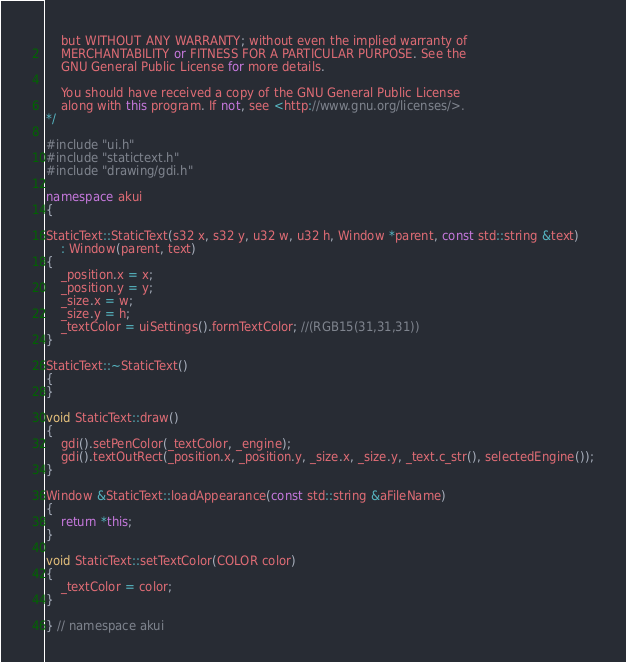<code> <loc_0><loc_0><loc_500><loc_500><_C++_>    but WITHOUT ANY WARRANTY; without even the implied warranty of
    MERCHANTABILITY or FITNESS FOR A PARTICULAR PURPOSE. See the
    GNU General Public License for more details.

    You should have received a copy of the GNU General Public License
    along with this program. If not, see <http://www.gnu.org/licenses/>.
*/

#include "ui.h"
#include "statictext.h"
#include "drawing/gdi.h"

namespace akui
{

StaticText::StaticText(s32 x, s32 y, u32 w, u32 h, Window *parent, const std::string &text)
    : Window(parent, text)
{
    _position.x = x;
    _position.y = y;
    _size.x = w;
    _size.y = h;
    _textColor = uiSettings().formTextColor; //(RGB15(31,31,31))
}

StaticText::~StaticText()
{
}

void StaticText::draw()
{
    gdi().setPenColor(_textColor, _engine);
    gdi().textOutRect(_position.x, _position.y, _size.x, _size.y, _text.c_str(), selectedEngine());
}

Window &StaticText::loadAppearance(const std::string &aFileName)
{
    return *this;
}

void StaticText::setTextColor(COLOR color)
{
    _textColor = color;
}

} // namespace akui
</code> 